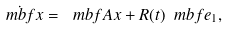Convert formula to latex. <formula><loc_0><loc_0><loc_500><loc_500>\dot { \ m b f { x } } = \ m b f { A x } + R ( t ) \ m b f { e } _ { 1 } ,</formula> 